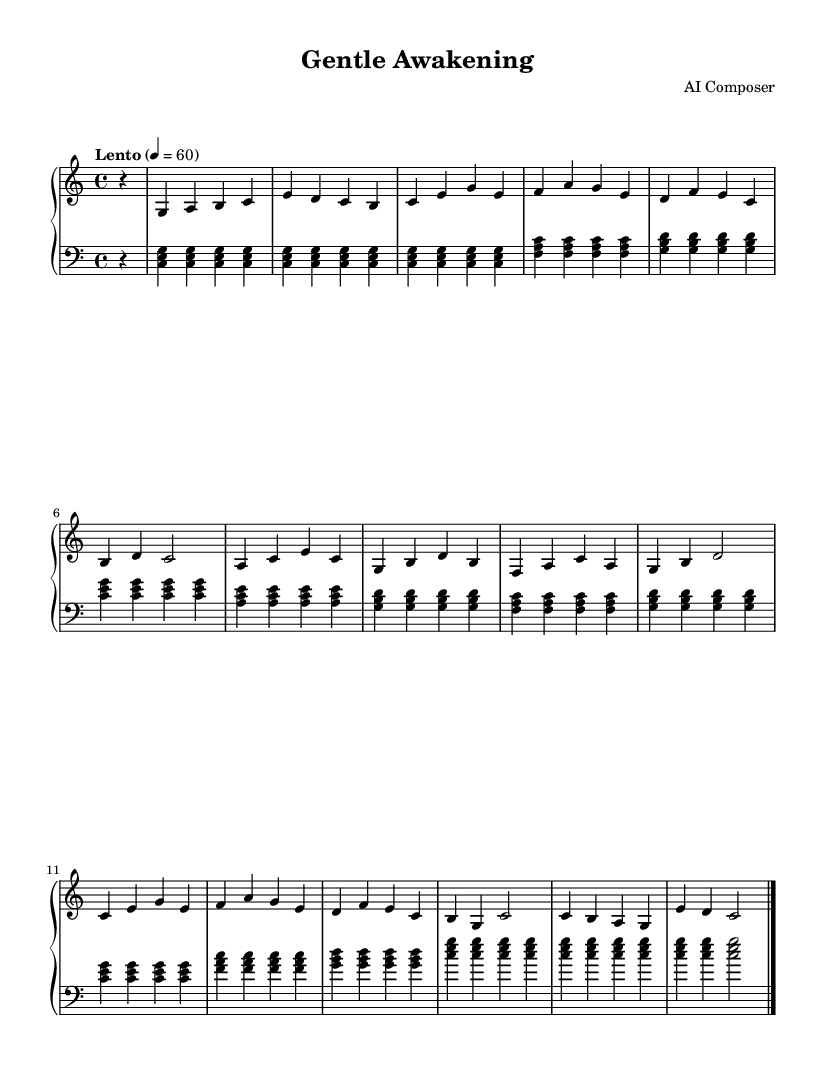what is the key signature of this music? The key signature of the music is indicated at the beginning as C major, which has no sharps or flats in its signature.
Answer: C major what is the time signature of this piece? The time signature is shown at the beginning of the score, represented as 4/4, which means there are four beats in each measure and a quarter note gets one beat.
Answer: 4/4 what is the tempo marking for this piece? The tempo marking is found in the header and reads "Lento," indicating a slow pace, along with a metronome marking of 60 beats per minute.
Answer: Lento how many measures are in the score? By counting the distinct rhythmic groups, we can see there are a total of 16 measures throughout the piece, as separated by bar lines.
Answer: 16 what is the style or mood this piece conveys? The gentle and flowing nature of the melody, alongside the consistent harmonic support from the left hand, suggests a calming and serene mood suitable for recovery.
Answer: Calming how many staff members are used in this score? This score consists of two staves, one for the right hand and one for the left hand, indicating that it is intended for piano performance.
Answer: Two 